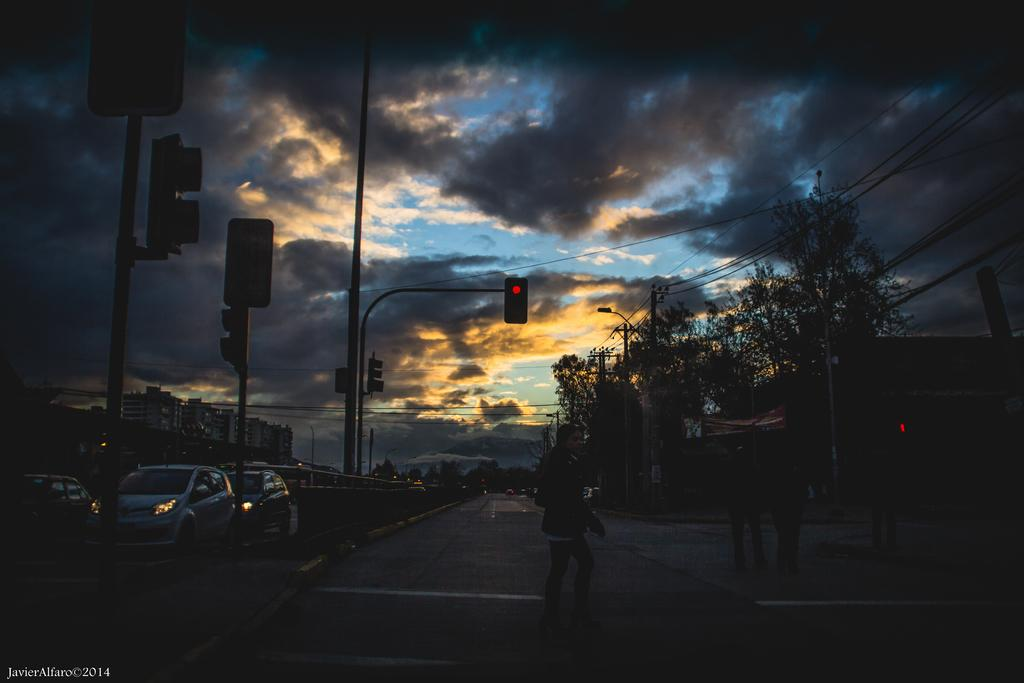What types of objects can be seen in the image? There are vehicles, sign boards, light poles, wires, current poles, trees, traffic signals, and buildings visible in the image. What is the color of the sky in the image? The sky is blue and white in color. How would you describe the overall lighting in the image? The image is dark. What type of agreement is being discussed in the image? There is no discussion or agreement present in the image; it primarily features vehicles, sign boards, light poles, wires, current poles, trees, traffic signals, and buildings. 